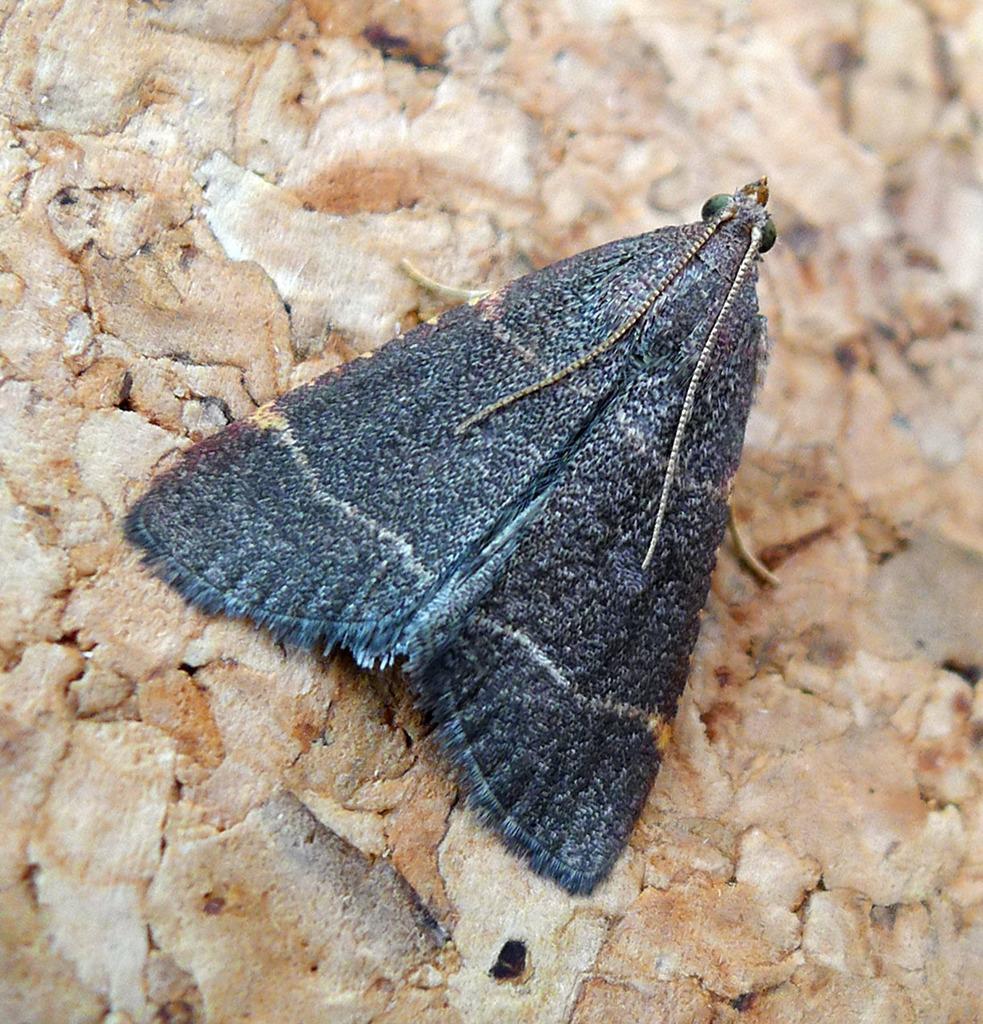Describe this image in one or two sentences. In this image there is an insect on the ground. 